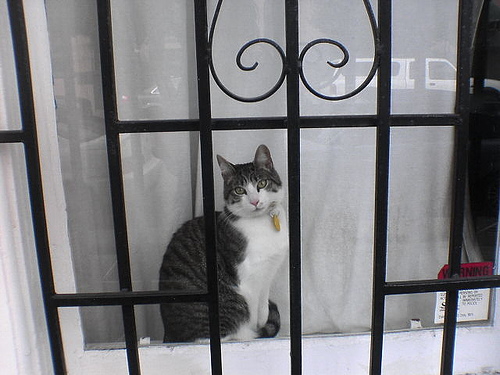Extract all visible text content from this image. WARNING 